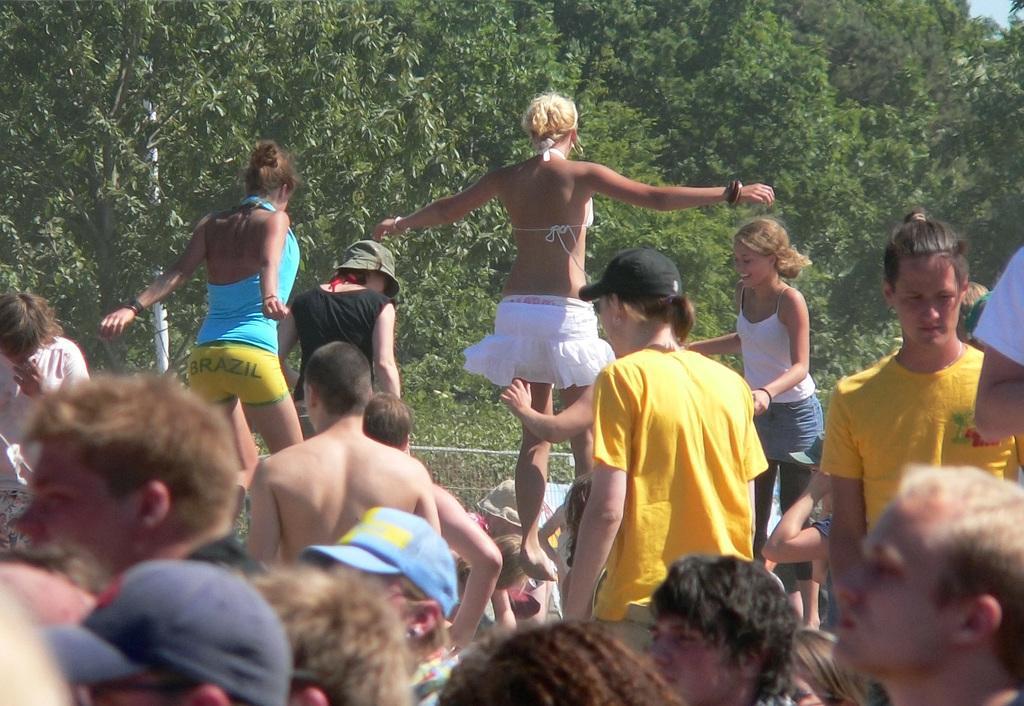Please provide a concise description of this image. In the picture I can see a few persons. I can see two women jumping and there is another woman on the right side is smiling. In the background, I can see the trees. 